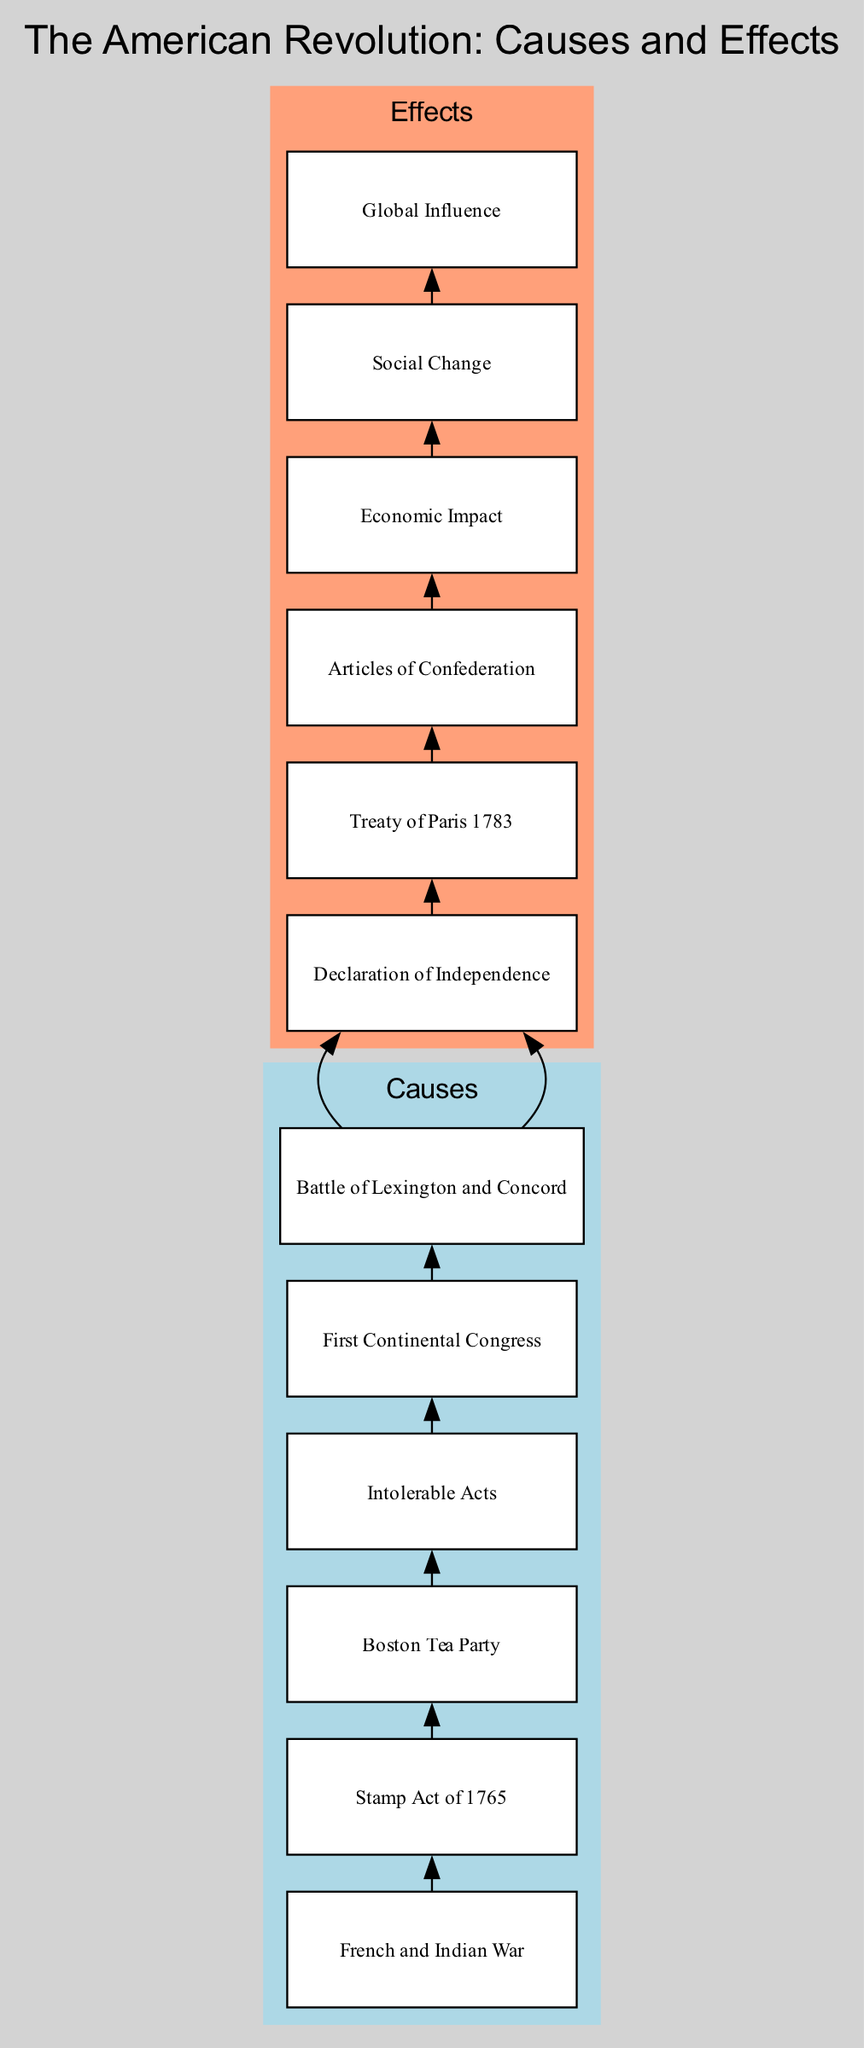What is the first military engagement of the Revolution? The diagram clearly indicates that the "Battle of Lexington and Concord" is the node representing the first military engagement. This node is connected to the preceding nodes that show the progression of events leading up to it.
Answer: Battle of Lexington and Concord How many causes are listed in the diagram? The diagram has a cluster labeled "Causes" which contains six distinct nodes that represent different events or actions leading to the American Revolution. Counting these nodes indicates the total number of causes.
Answer: 6 What legislation imposed a direct tax on paper goods? The "Stamp Act of 1765" is identified in the "Causes" section of the diagram, and it specifically states that it imposed a direct tax on the colonies for paper goods.
Answer: Stamp Act of 1765 What document was adopted declaring independence from Britain? The diagram points to the "Declaration of Independence" as the node that explicitly states it was adopted on July 4, 1776, for the purpose of declaring independence from Britain.
Answer: Declaration of Independence Which event led to a series of punitive measures by Britain? The diagram links "Boston Tea Party" to "Intolerable Acts," thus indicating that the Boston Tea Party was the triggering event that led to the punitive measures known as the Intolerable Acts.
Answer: Boston Tea Party What was the outcome of the Revolutionary War recognized in 1783? According to the diagram, the "Treaty of Paris 1783" is the node that indicates it was the agreement that formally ended the Revolutionary War and recognized American independence.
Answer: Treaty of Paris 1783 What is the first constitution of the United States mentioned in the diagram? The diagram shows the "Articles of Confederation" as the first constitution of the United States, detailed under the "Effects" section.
Answer: Articles of Confederation What type of change did the Revolution inspire regarding rights and freedoms? The node labeled "Social Change" indicates that the Revolution led to increased calls for rights and freedoms, signaling significant societal impacts through the connected nodes.
Answer: Social Change Which event directly follows the Intolerable Acts in the sequence of causes? Following the "Intolerable Acts" node, the "First Continental Congress" node is connected, which shows that it directly follows in the progression of events leading to the Revolution.
Answer: First Continental Congress 